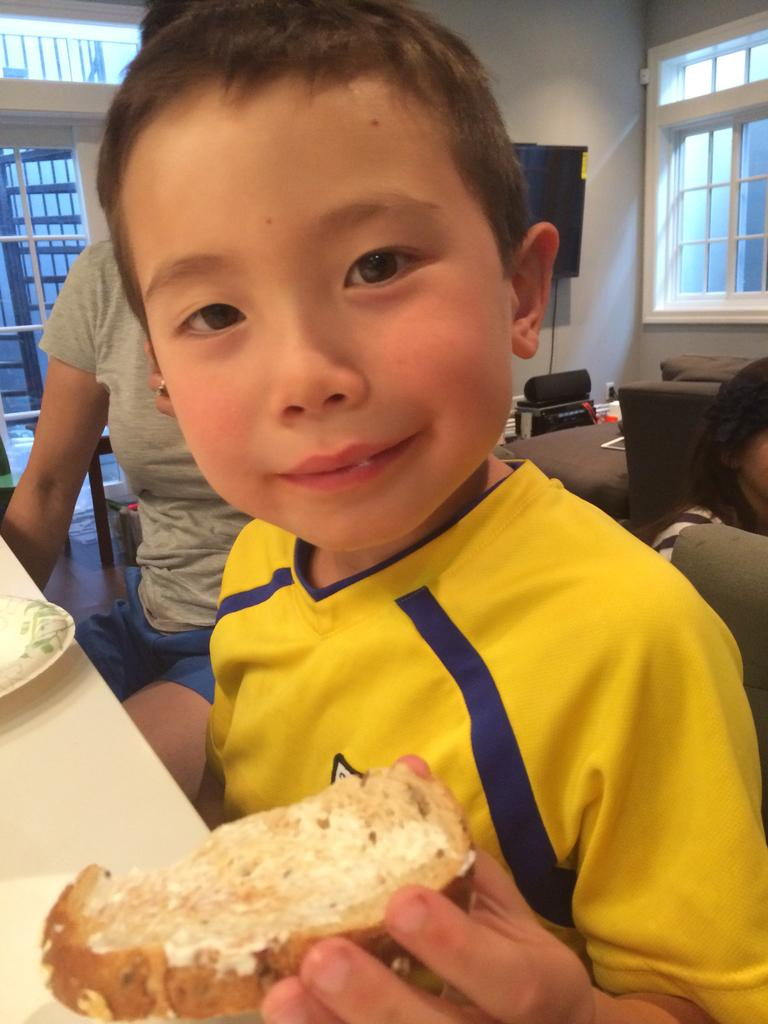What is the kid in the image doing? The kid is sitting in the image. What is the kid holding? The kid is holding a food item. What is present in the image for placing objects? There is a table in the image. How many people are visible behind the kid? There are two people behind the kid. What can be seen on the wall in the image? There is a wall visible in the image. What allows natural light to enter the room in the image? There are windows in the image. What type of leather is being used to make the farmer's hat in the image? There is no farmer or hat present in the image. 